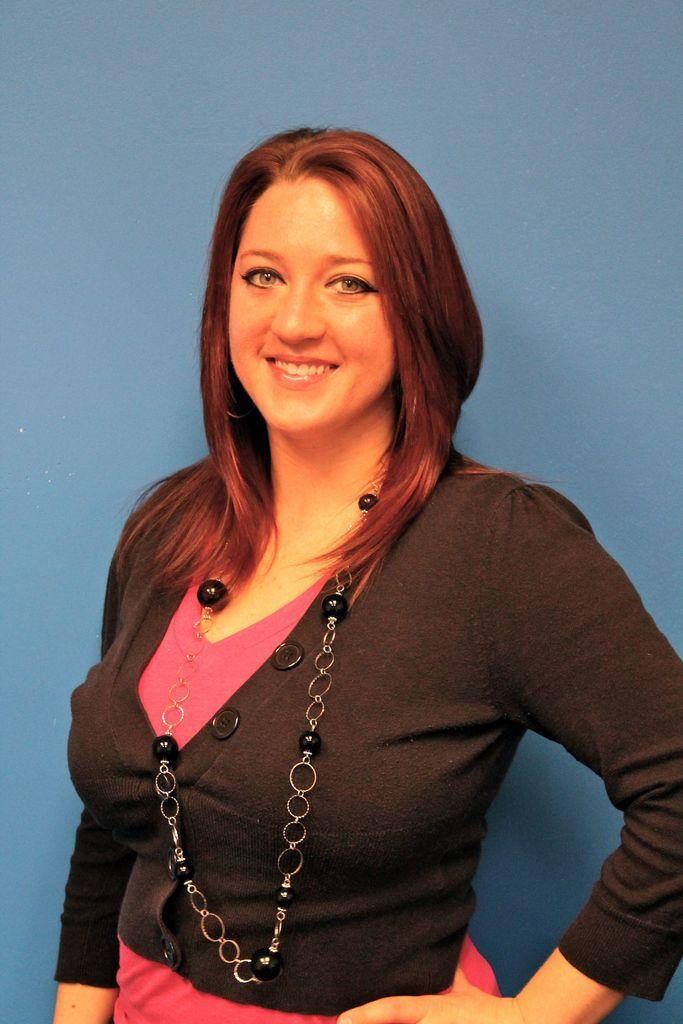Who is the main subject in the foreground of the image? There is a woman in the foreground of the image. What is the woman wearing? The woman is wearing a black jacket. What expression does the woman have? The woman is smiling. What can be seen in the background of the image? There is a wall in the background of the image. What type of trouble is the woman facing in the image? There is no indication of trouble in the image. The woman is smiling, and there is no context provided to suggest any trouble. --- Facts: 1. There is a car in the image. 2. The car is red. 3. The car has four wheels. 4. There are people standing near the car. 5. The people are holding bags. Absurd Topics: unicorn, flying saucer, invisible ink Conversation: What is the main subject in the image? There is a car in the image. What color is the car? The car is red. How many wheels does the car have? The car has four wheels. What are the people near the car doing? The people are standing near the car and holding bags. Reasoning: Let's think step by step in order to produce the conversation. We start by identifying the main subject in the image, which is the car. Then, we describe the car's color, specifically mentioning that the car is red. Next, we count the number of wheels the car has, which is four. Finally, we observe the actions of the people in the image, noting that they are standing near the car and holding bags. Absurd Question/Answer: Can you see a unicorn in the image? No, there is no unicorn present in the image. --- Facts: 1. There is a train. 2. The train is moving. 3. There are passengers inside the train. 4. The train is passing through a forest. Absurd Topics: giant squid, underwater volcano, space alien Conversation: What is the main subject in the image? The main subject in the image is a train. What is the train doing? The train is moving. Who or what is inside the train? There are passengers inside the train. What is the setting of the image? The train is passing through a forest. Reasoning: Let's think step by step in order to produce the conversation. We start by identifying the main subject in the image, which is the train. Then, we describe the train's action, specifically mentioning that the train is moving. Next, we observe the passengers inside the train. Finally, we describe the setting of the image, noting that the train is passing through a forest. Absurd Question/Answer: Is there a giant squid visible in the image? No, 